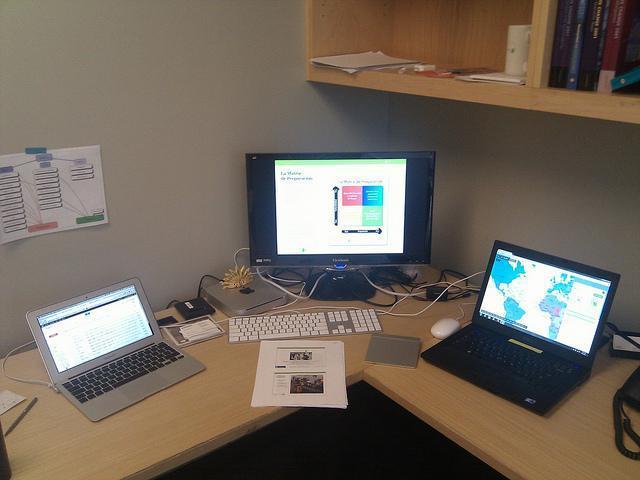How many desktop monitors are shown?
Give a very brief answer. 1. How many computers are there?
Give a very brief answer. 3. How many monitors are shown?
Give a very brief answer. 3. How many keyboards can you see?
Give a very brief answer. 3. How many books are there?
Give a very brief answer. 2. How many laptops can be seen?
Give a very brief answer. 2. 